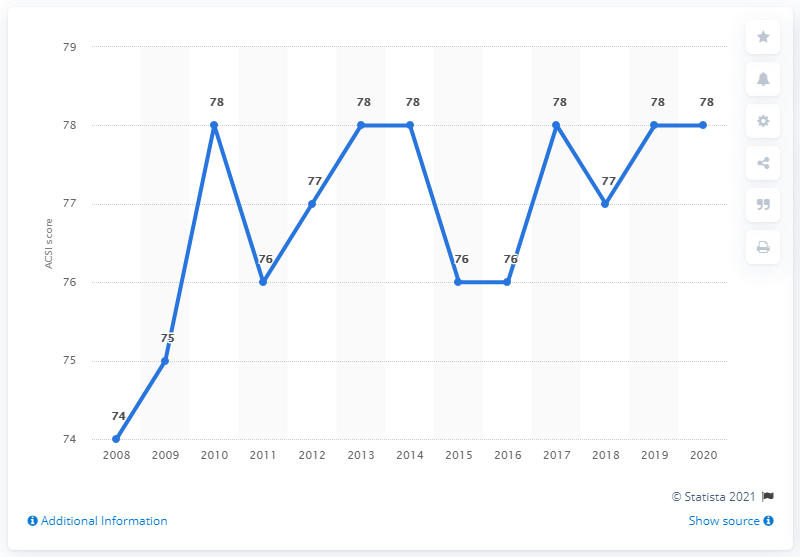Draw attention to some important aspects in this diagram. The American Customer Satisfaction Index (ACSI) score for InterContinental Hotels was 78 for two consecutive years. In 2010, InterContinental's highest score was 76. 